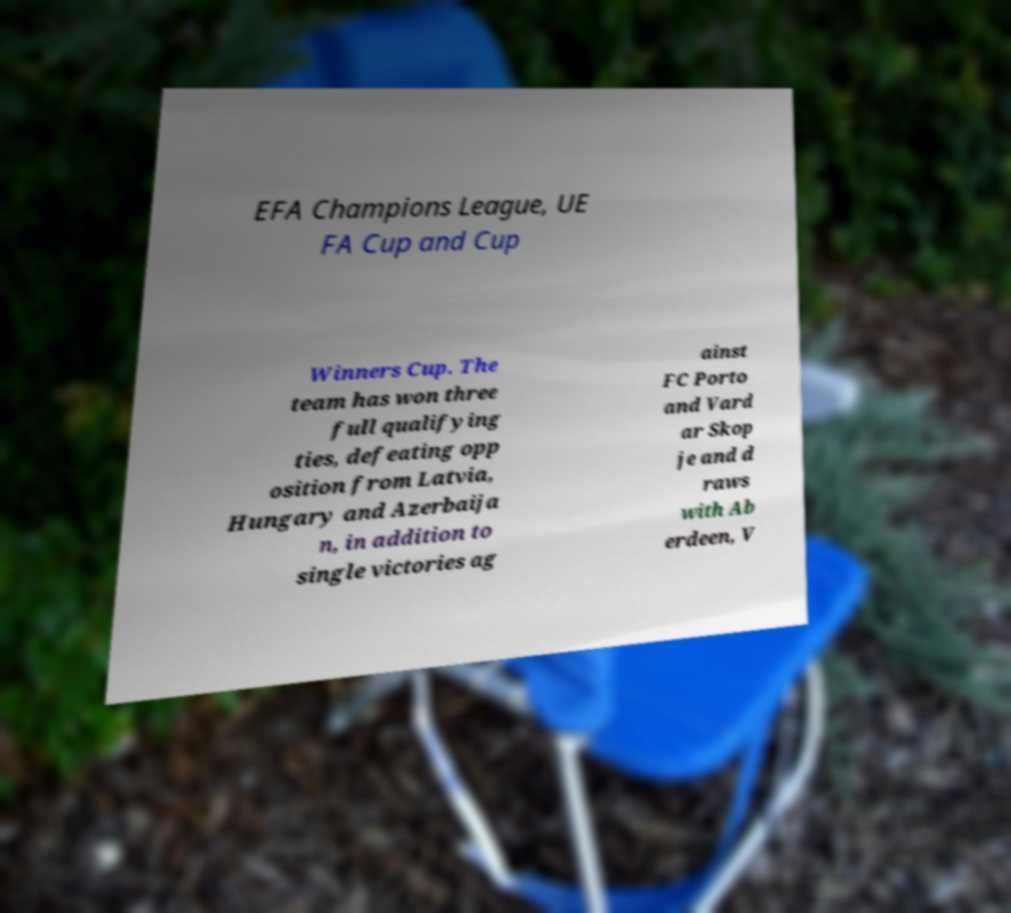For documentation purposes, I need the text within this image transcribed. Could you provide that? EFA Champions League, UE FA Cup and Cup Winners Cup. The team has won three full qualifying ties, defeating opp osition from Latvia, Hungary and Azerbaija n, in addition to single victories ag ainst FC Porto and Vard ar Skop je and d raws with Ab erdeen, V 